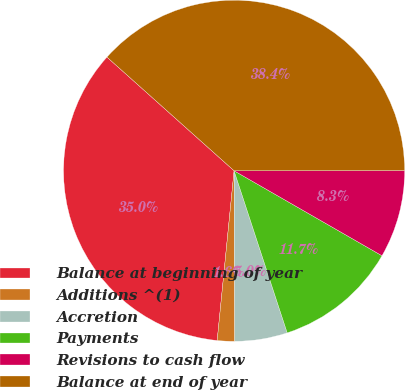Convert chart. <chart><loc_0><loc_0><loc_500><loc_500><pie_chart><fcel>Balance at beginning of year<fcel>Additions ^(1)<fcel>Accretion<fcel>Payments<fcel>Revisions to cash flow<fcel>Balance at end of year<nl><fcel>35.03%<fcel>1.64%<fcel>4.98%<fcel>11.66%<fcel>8.32%<fcel>38.37%<nl></chart> 